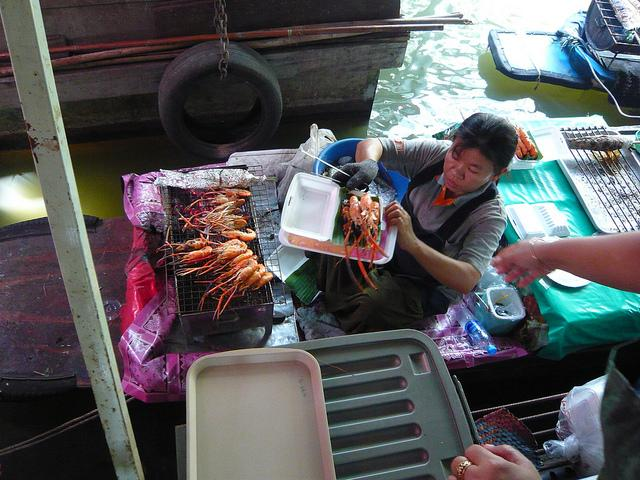What is this person's profession? Please explain your reasoning. fisherman. He is a fisherman and you can see his boat there too. 